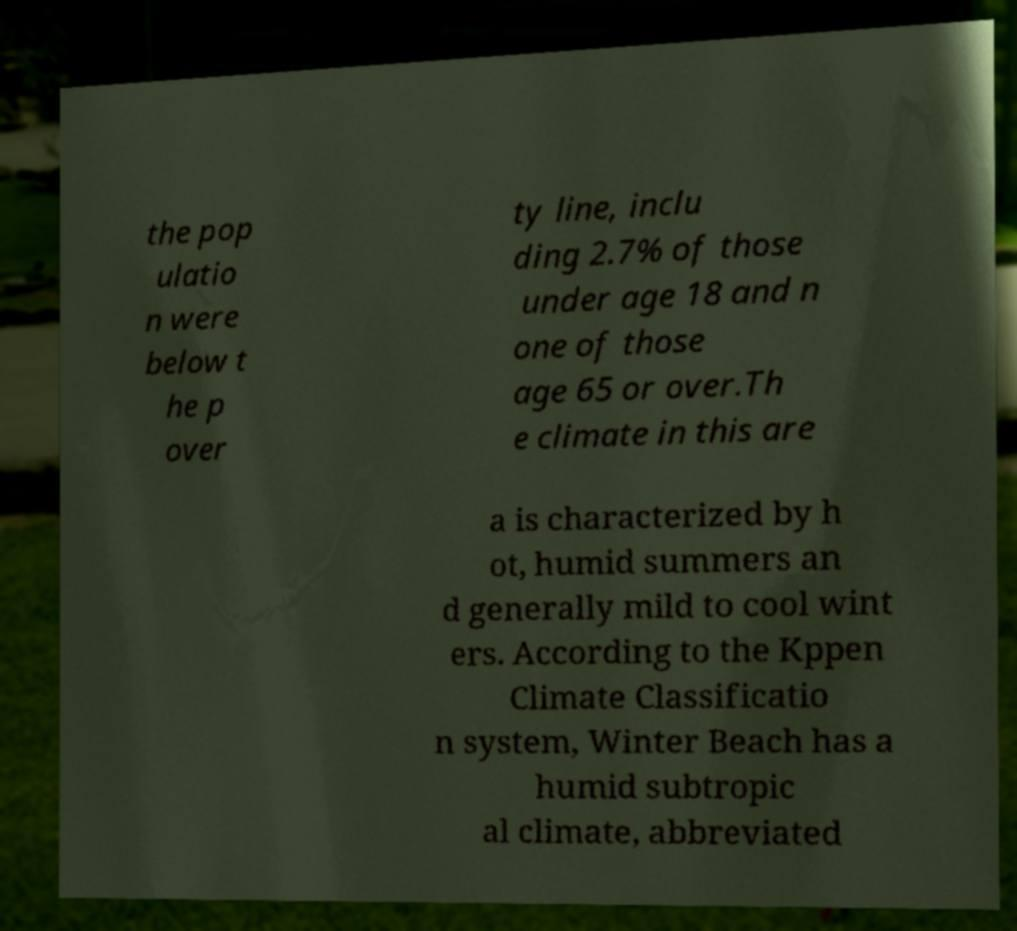I need the written content from this picture converted into text. Can you do that? the pop ulatio n were below t he p over ty line, inclu ding 2.7% of those under age 18 and n one of those age 65 or over.Th e climate in this are a is characterized by h ot, humid summers an d generally mild to cool wint ers. According to the Kppen Climate Classificatio n system, Winter Beach has a humid subtropic al climate, abbreviated 